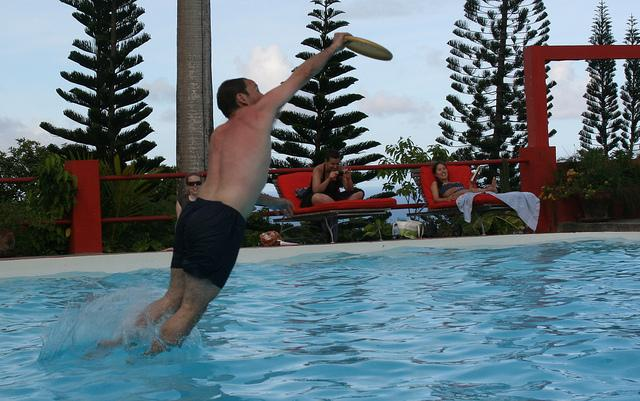Where is the man while he is swimming? Please explain your reasoning. in pool. The man is in the pool. 